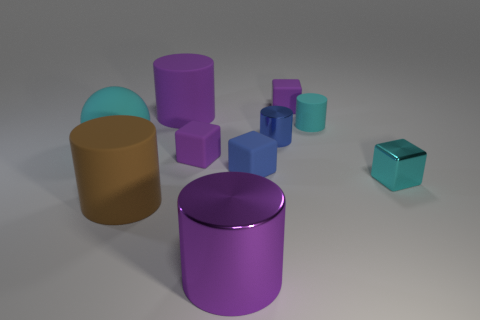Subtract all blue cylinders. How many cylinders are left? 4 Subtract all red cylinders. Subtract all gray spheres. How many cylinders are left? 5 Subtract all balls. How many objects are left? 9 Subtract 0 gray cylinders. How many objects are left? 10 Subtract all brown blocks. Subtract all small cyan objects. How many objects are left? 8 Add 4 blue cubes. How many blue cubes are left? 5 Add 6 blue matte blocks. How many blue matte blocks exist? 7 